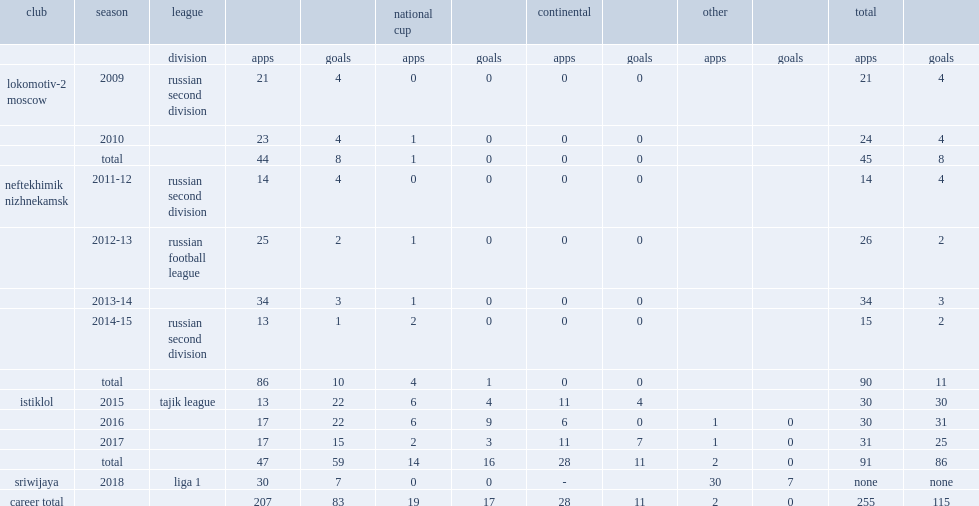In 2018, which league have dzhalilov joined side sriwijaya? Liga 1. 